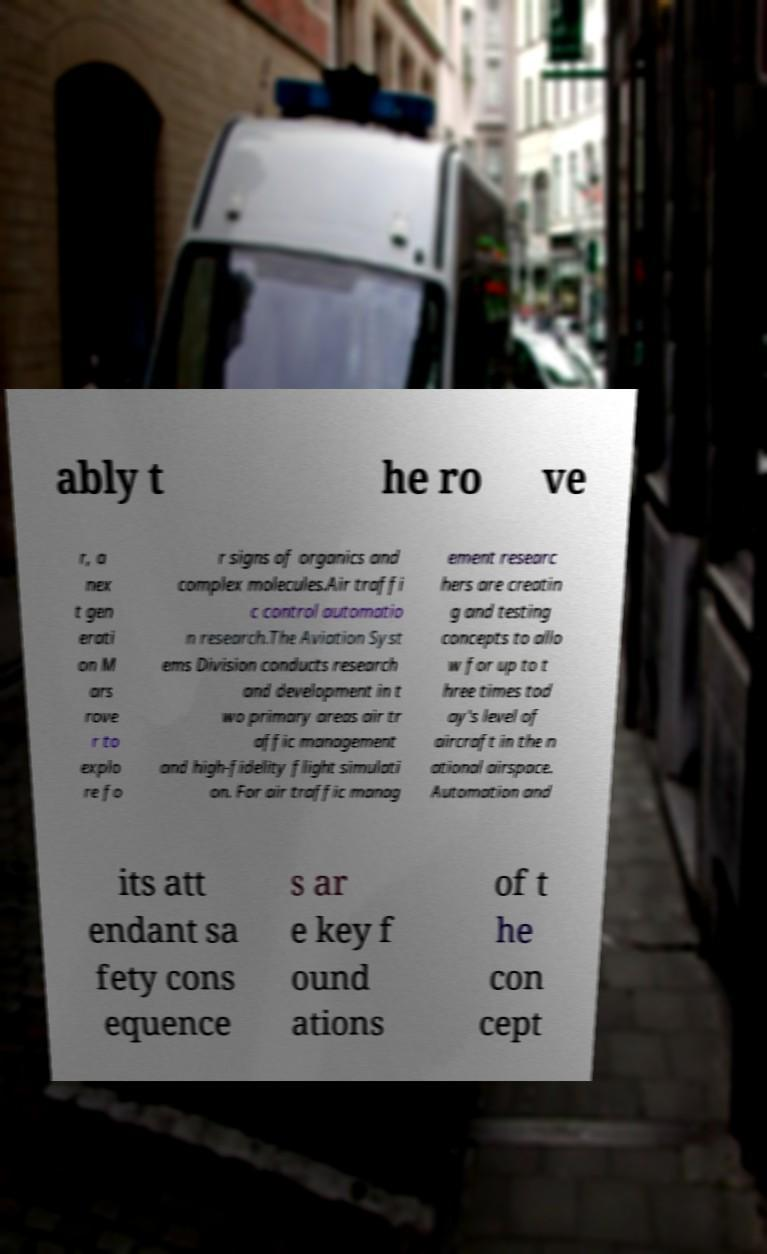Please read and relay the text visible in this image. What does it say? ably t he ro ve r, a nex t gen erati on M ars rove r to explo re fo r signs of organics and complex molecules.Air traffi c control automatio n research.The Aviation Syst ems Division conducts research and development in t wo primary areas air tr affic management and high-fidelity flight simulati on. For air traffic manag ement researc hers are creatin g and testing concepts to allo w for up to t hree times tod ay's level of aircraft in the n ational airspace. Automation and its att endant sa fety cons equence s ar e key f ound ations of t he con cept 